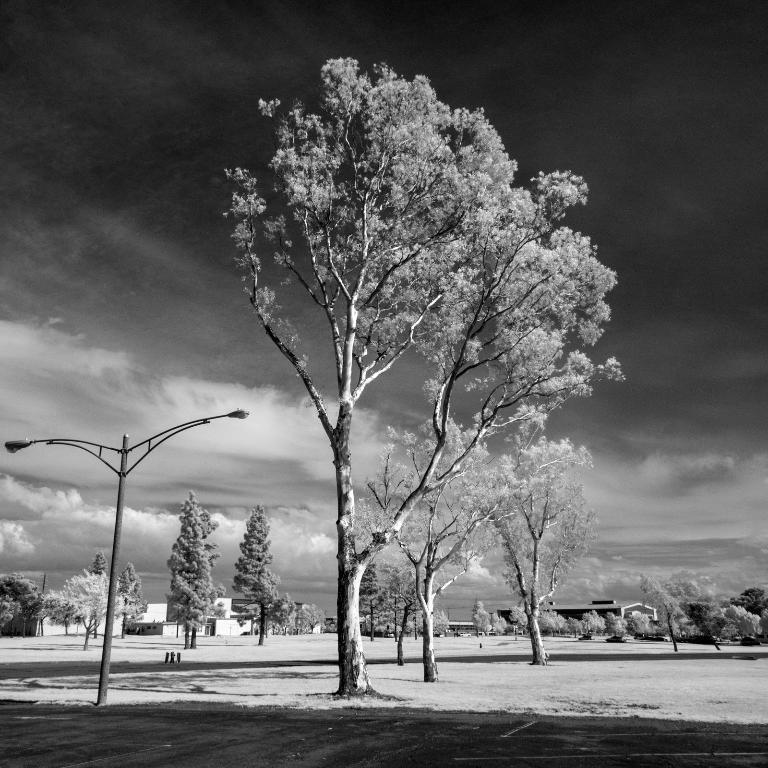What is the color scheme of the image? The image is black and white. What can be seen on the ground in the image? There are trees on the ground in the image. What is located on the left side of the image? There is a street light pole on the left side of the image. What type of vegetation is visible in the background of the image? There are trees in the background of the image. What is visible at the top of the image? The sky is visible at the top of the image. Can you tell me how many wrens are perched on the street light pole in the image? There are no wrens present in the image; the image is black and white and does not depict any birds. What type of appliance can be seen plugged into the street light pole in the image? There is no appliance present in the image; the image only shows a street light pole, trees, and a black and white color scheme. 